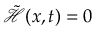Convert formula to latex. <formula><loc_0><loc_0><loc_500><loc_500>\tilde { \mathcal { H } } ( x , t ) = 0</formula> 